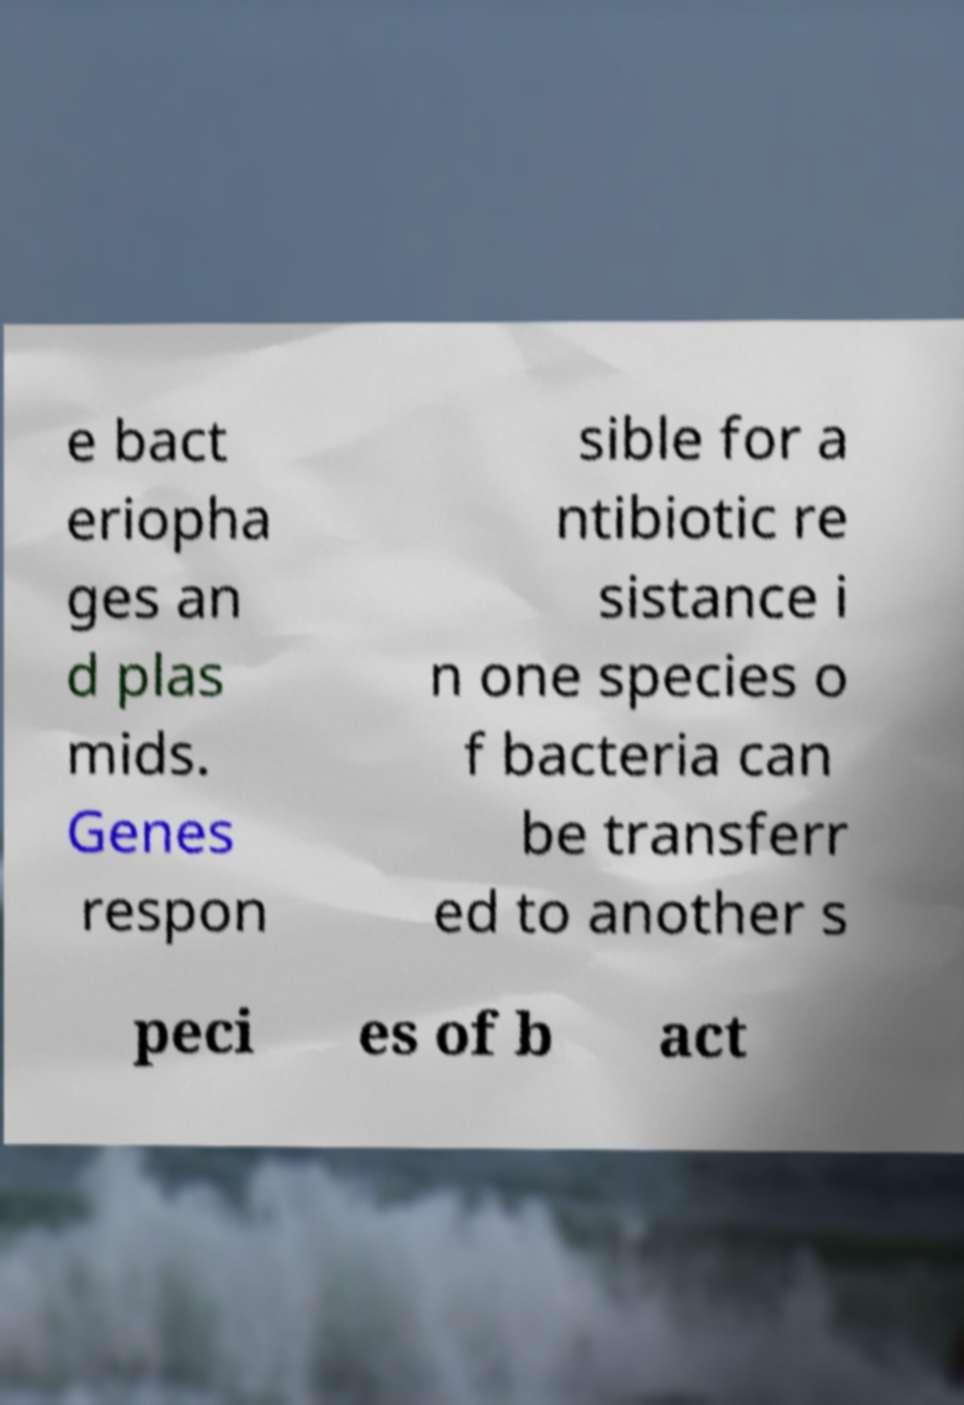Can you accurately transcribe the text from the provided image for me? e bact eriopha ges an d plas mids. Genes respon sible for a ntibiotic re sistance i n one species o f bacteria can be transferr ed to another s peci es of b act 